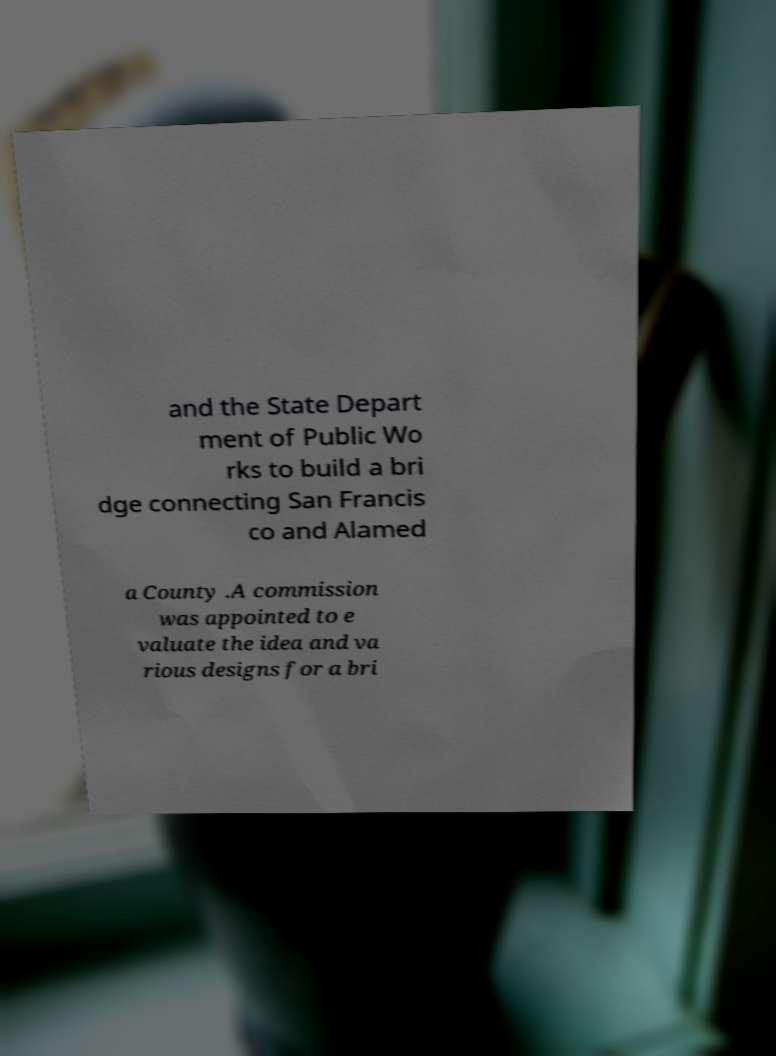For documentation purposes, I need the text within this image transcribed. Could you provide that? and the State Depart ment of Public Wo rks to build a bri dge connecting San Francis co and Alamed a County .A commission was appointed to e valuate the idea and va rious designs for a bri 